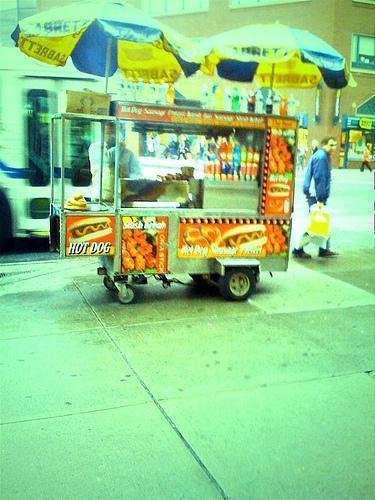What type of food is advertised on the cart?
Select the accurate answer and provide explanation: 'Answer: answer
Rationale: rationale.'
Options: Muffin, hot dog, hamburger, bagel. Answer: hot dog.
Rationale: The white text on the left of the cart is the advertisement for this type of food. it consists of a bun, a sausage, and condiments. 